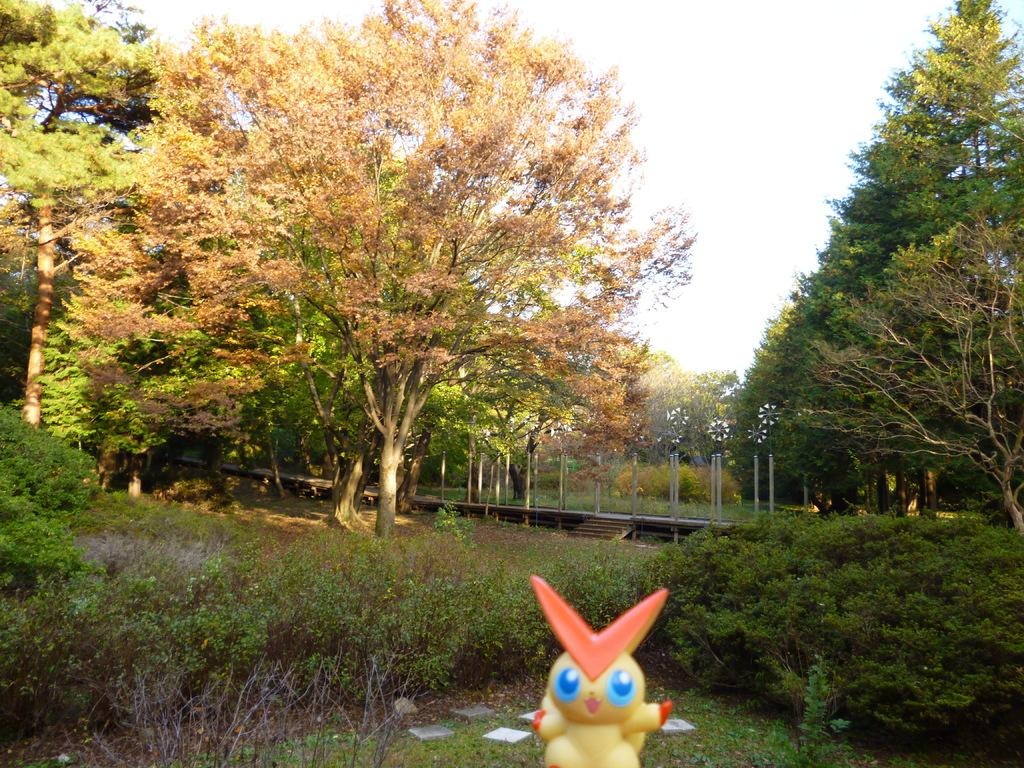What object can be seen in the image that is typically used for play? There is a toy in the image. What type of vegetation is present in the image? There are plants and grass in the image. What structure can be seen in the image that allows people to cross over a body of water? There is a wooden bridge in the image. What type of natural environment is visible in the image? There are trees in the image, which suggests a natural environment. What part of the natural environment is visible in the background of the image? The sky is visible in the background of the image. What word is written on the church in the image? There is no church present in the image, so it is not possible to answer that question. 